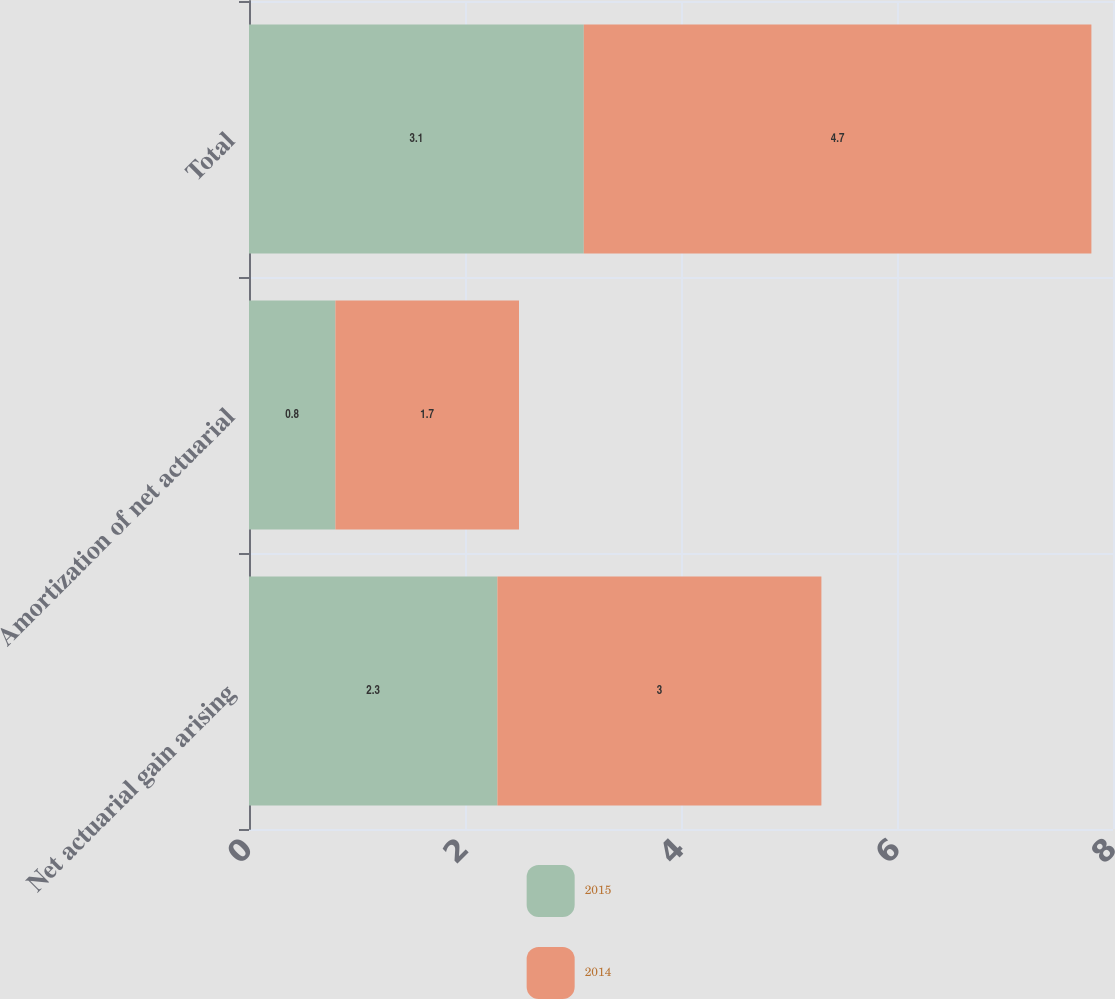Convert chart. <chart><loc_0><loc_0><loc_500><loc_500><stacked_bar_chart><ecel><fcel>Net actuarial gain arising<fcel>Amortization of net actuarial<fcel>Total<nl><fcel>2015<fcel>2.3<fcel>0.8<fcel>3.1<nl><fcel>2014<fcel>3<fcel>1.7<fcel>4.7<nl></chart> 